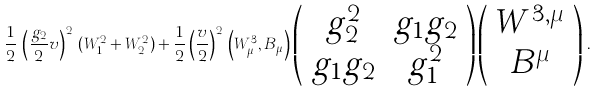Convert formula to latex. <formula><loc_0><loc_0><loc_500><loc_500>\frac { 1 } { 2 } \, \left ( \frac { g _ { 2 } } { 2 } v \right ) ^ { 2 } \, ( W _ { 1 } ^ { 2 } + W _ { 2 } ^ { 2 } ) + \frac { 1 } { 2 } \left ( \frac { v } { 2 } \right ) ^ { 2 } \, \left ( W _ { \mu } ^ { 3 } , B _ { \mu } \right ) \left ( \begin{array} { c c } g _ { 2 } ^ { 2 } & g _ { 1 } g _ { 2 } \\ g _ { 1 } g _ { 2 } & g _ { 1 } ^ { 2 } \end{array} \right ) \left ( \begin{array} { c } W ^ { 3 , \mu } \\ B ^ { \mu } \end{array} \right ) \, .</formula> 